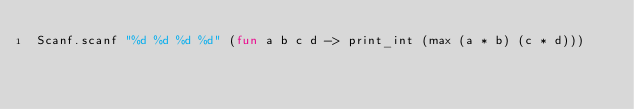Convert code to text. <code><loc_0><loc_0><loc_500><loc_500><_OCaml_>Scanf.scanf "%d %d %d %d" (fun a b c d -> print_int (max (a * b) (c * d)))
</code> 